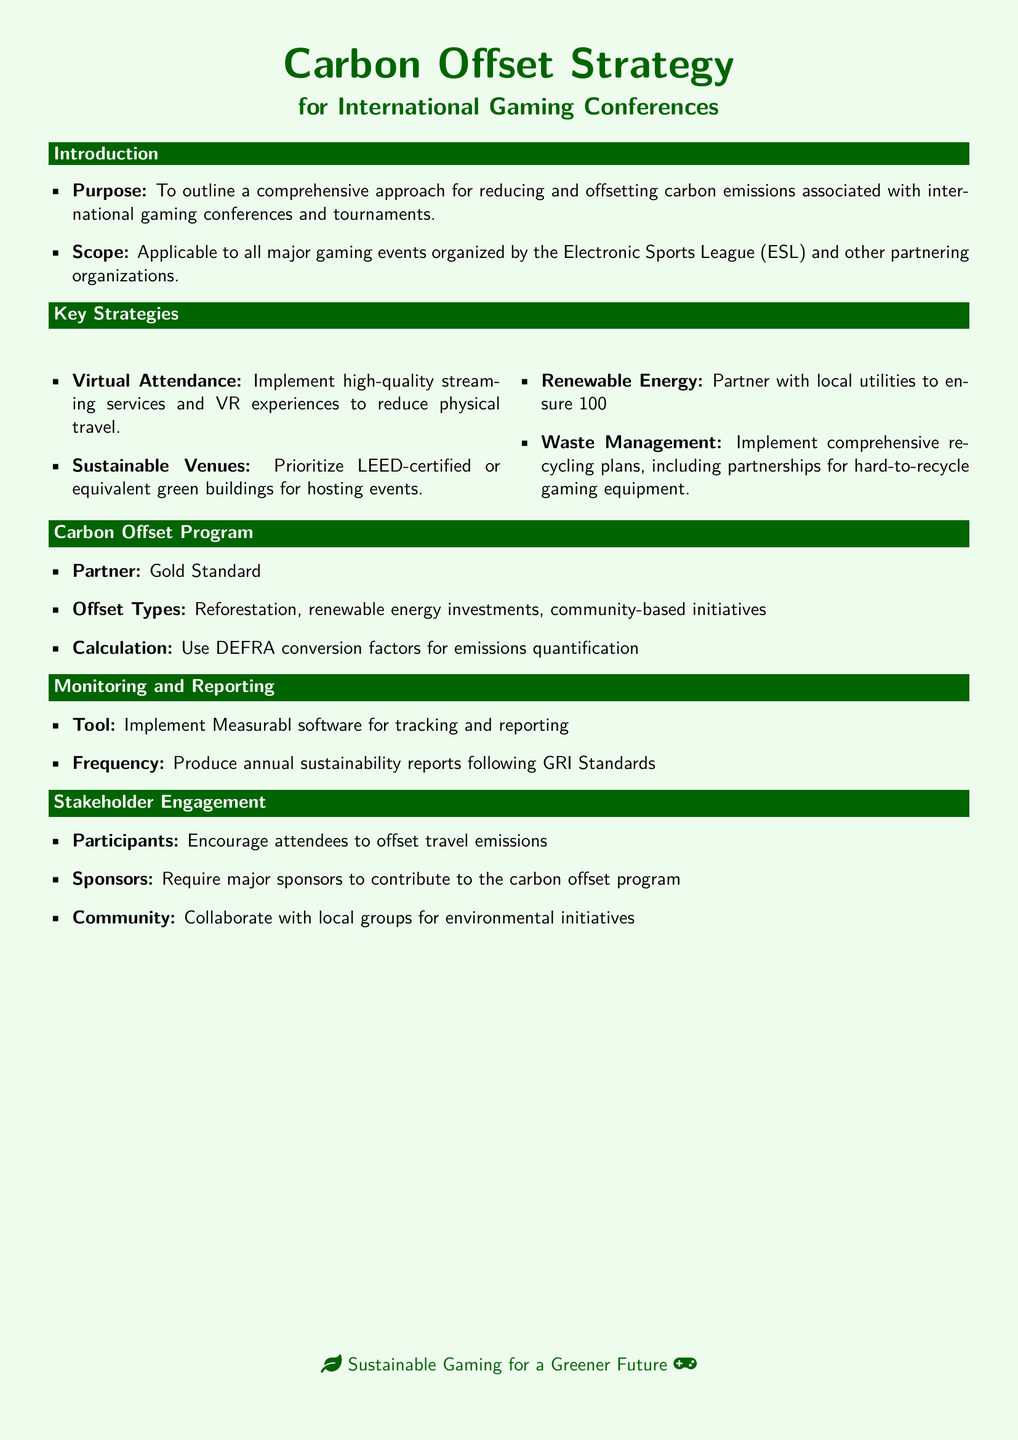What is the purpose of the document? The purpose is to outline a comprehensive approach for reducing and offsetting carbon emissions associated with international gaming conferences and tournaments.
Answer: To outline a comprehensive approach for reducing and offsetting carbon emissions What organization is specifically mentioned in relation to the events? The document states that the strategies are applicable to all major gaming events organized by the Electronic Sports League.
Answer: Electronic Sports League (ESL) What type of energy does the strategy propose to use? The strategy involves partnering with local utilities to ensure energy sourcing.
Answer: Renewable energy Who is the partner for the Carbon Offset Program? The document specifies a partner for the Carbon Offset Program.
Answer: Gold Standard Which software is recommended for monitoring and reporting? The document points to a specific tool for tracking and reporting.
Answer: Measurabl How often should sustainability reports be produced? The document states the frequency for producing sustainability reports.
Answer: Annual What type of venues does the strategy prioritize? The strategy emphasizes specific types of venues for hosting events.
Answer: LEED-certified or equivalent green buildings What is one of the offset types mentioned in the document? The document lists different types of offsets.
Answer: Reforestation What is the expected outcome for attendees regarding travel emissions? The document mentions a specific action for attendees related to travel emissions.
Answer: Encourage attendees to offset travel emissions 